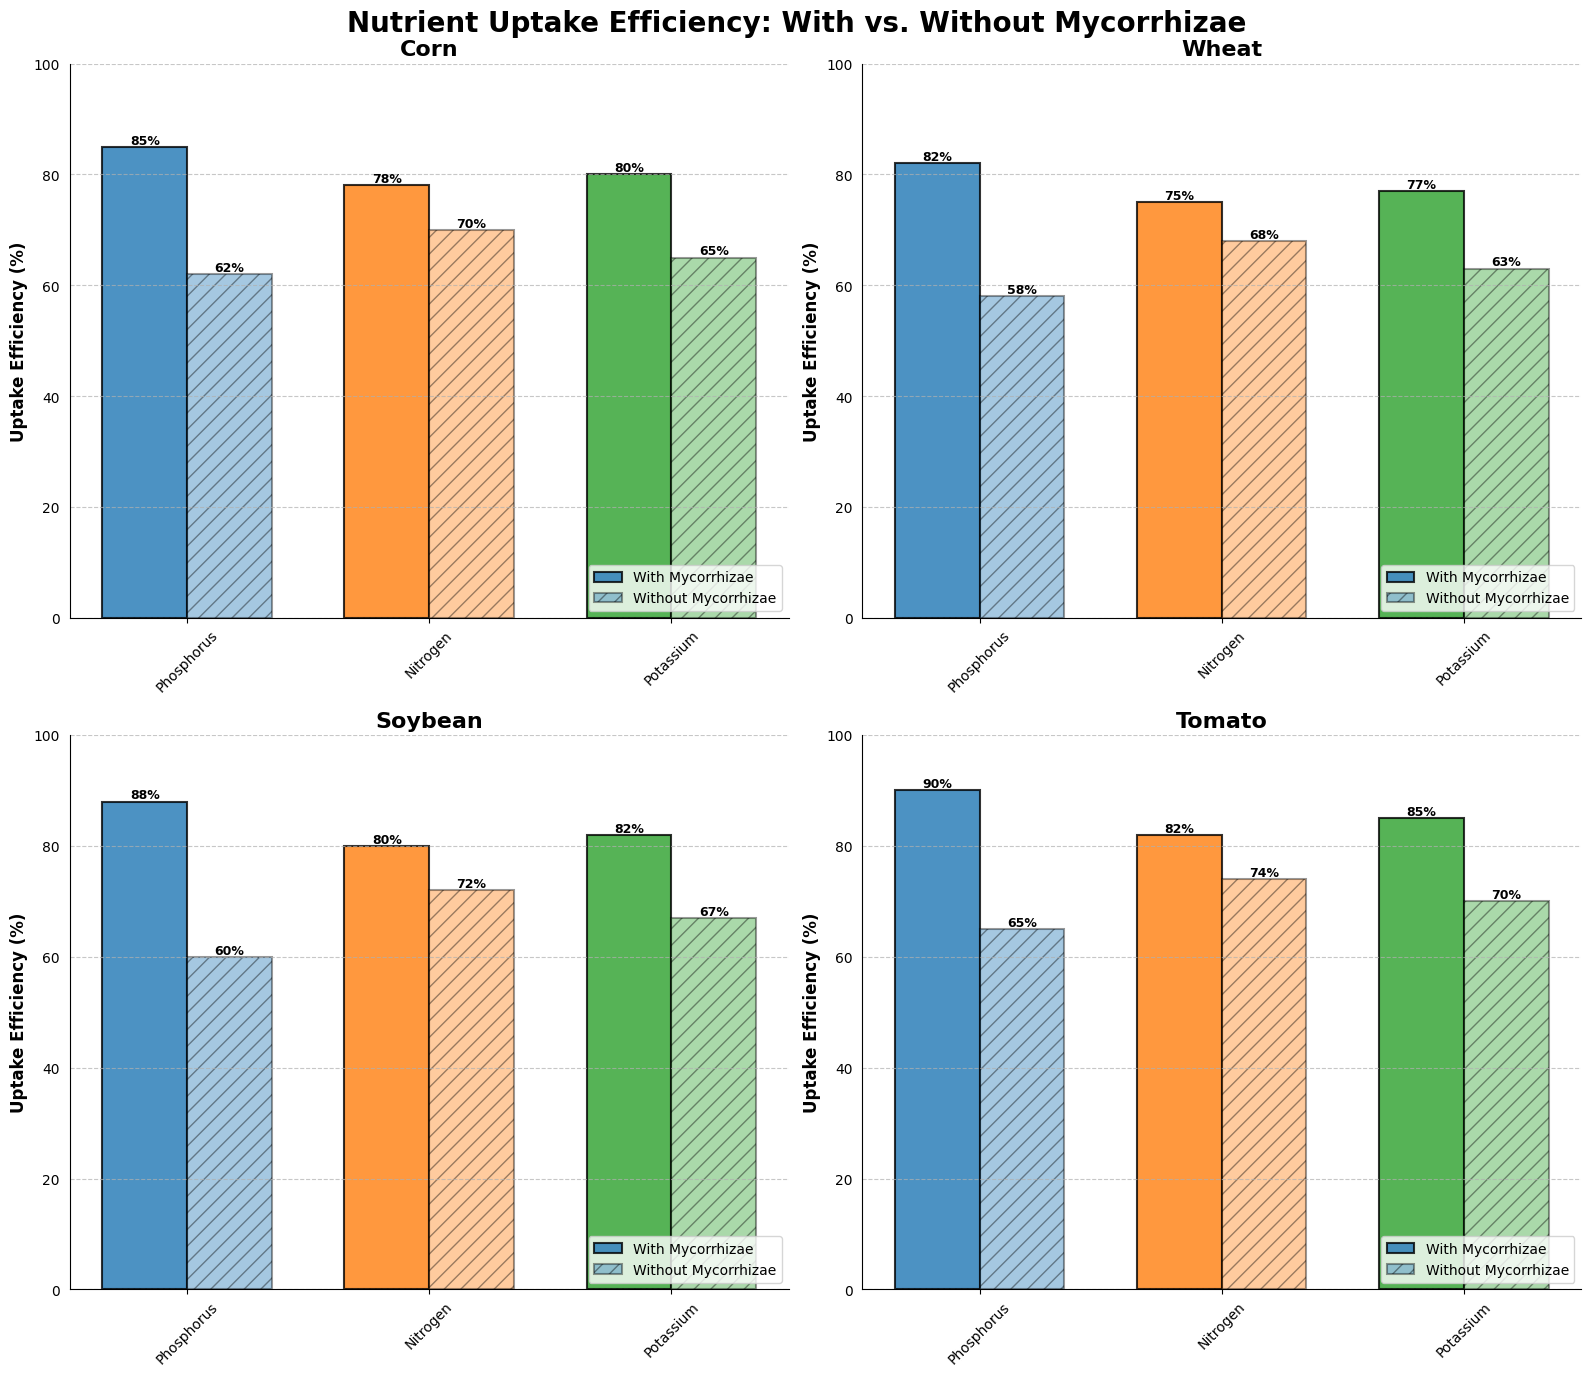Which crop shows the highest phosphorus uptake efficiency with mycorrhizae? By observing the bar heights in each subplot, the tomato crop shows the highest phosphorus uptake efficiency with mycorrhizae because its bar reaches 90%.
Answer: Tomato How much higher is the nitrogen uptake efficiency in soybeans with mycorrhizae compared to without mycorrhizae? Look at the heights of the nitrogen bars for soybeans in the subplot. With mycorrhizae, it is 80%, and without mycorrhizae, it is 72%. The difference is 80% - 72% = 8%.
Answer: 8% Which nutrient shows the least improvement in uptake efficiency for wheat when using mycorrhizae compared to without? Observe the differences in the bar heights for each nutrient in the wheat subplot. The improvement is least for nitrogen, as the difference is only 75% - 68% = 7%.
Answer: Nitrogen Across all crops, which nutrient consistently shows higher uptake efficiency with mycorrhizae compared to without? Check each subplot for all crops and observe the nutrient bar comparisons. Phosphorus consistently shows higher uptake efficiency across all crops with mycorrhizae.
Answer: Phosphorus How much does the potassium uptake efficiency increase with mycorrhizae for tomatoes? Look at the potassium bars in the tomato subplot. With mycorrhizae, the bar reaches 85%, and without mycorrhizae, it reaches 70%. The increase is 85% - 70% = 15%.
Answer: 15% What is the average phosphorus uptake efficiency for corn with mycorrhizae and without mycorrhizae? Add the uptake efficiencies for corn: (with mycorrhizae is 85% and without is 62%). The average is (85% + 62%) / 2 = 73.5%.
Answer: 73.5% In which crop is the difference in potassium uptake efficiency most significant when comparing mycorrhizal and non-mycorrhizal associations? Calculate the difference in potassium uptake efficiency for each crop. The tomato crop shows the largest difference, with a difference of 85% - 70% = 15%.
Answer: Tomato Is the nitrogen uptake efficiency of wheat higher or lower with mycorrhizae than the nitrogen uptake efficiency of corn without mycorrhizae? Compare the uptake efficiency of nitrogen for wheat with mycorrhizae (75%) and corn without mycorrhizae (70%). Since 75% > 70%, it is higher.
Answer: Higher Which crop shows the smallest overall improvement in nutrient uptake efficiency when using mycorrhizae compared to without? Calculate the average improvement for each crop: add differences in efficiencies for all nutrients and find the smallest average. Wheat shows smallest improvements (Phosphorus: 24, Nitrogen: 7, Potassium: 14; average is (24+7+14)/3 ≈ 15%).
Answer: Wheat What is the average difference in nutrient uptake efficiencies between with and without mycorrhizae for all nutrients across all crops? Find the difference for each nutrient in each crop and calculate the overall average: ((85-62) + (78-70) + (80-65) + (82-58) + (75-68) + (77-63) + (88-60) + (80-72) + (82-67) + (90-65) + (82-74) + (85-70)) / 12 ≈ 15.25%.
Answer: 15.25% 